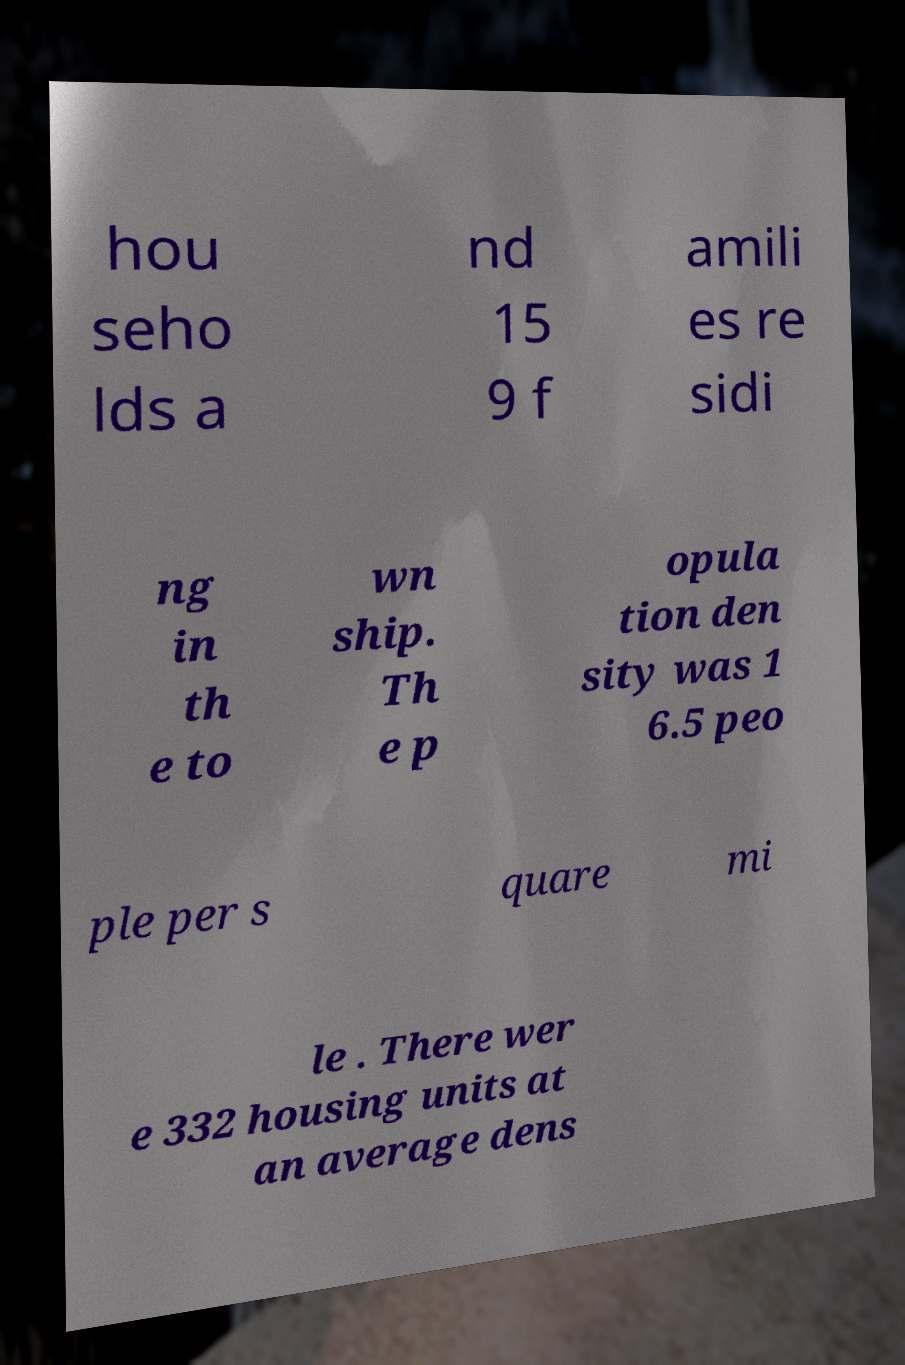Can you read and provide the text displayed in the image?This photo seems to have some interesting text. Can you extract and type it out for me? hou seho lds a nd 15 9 f amili es re sidi ng in th e to wn ship. Th e p opula tion den sity was 1 6.5 peo ple per s quare mi le . There wer e 332 housing units at an average dens 